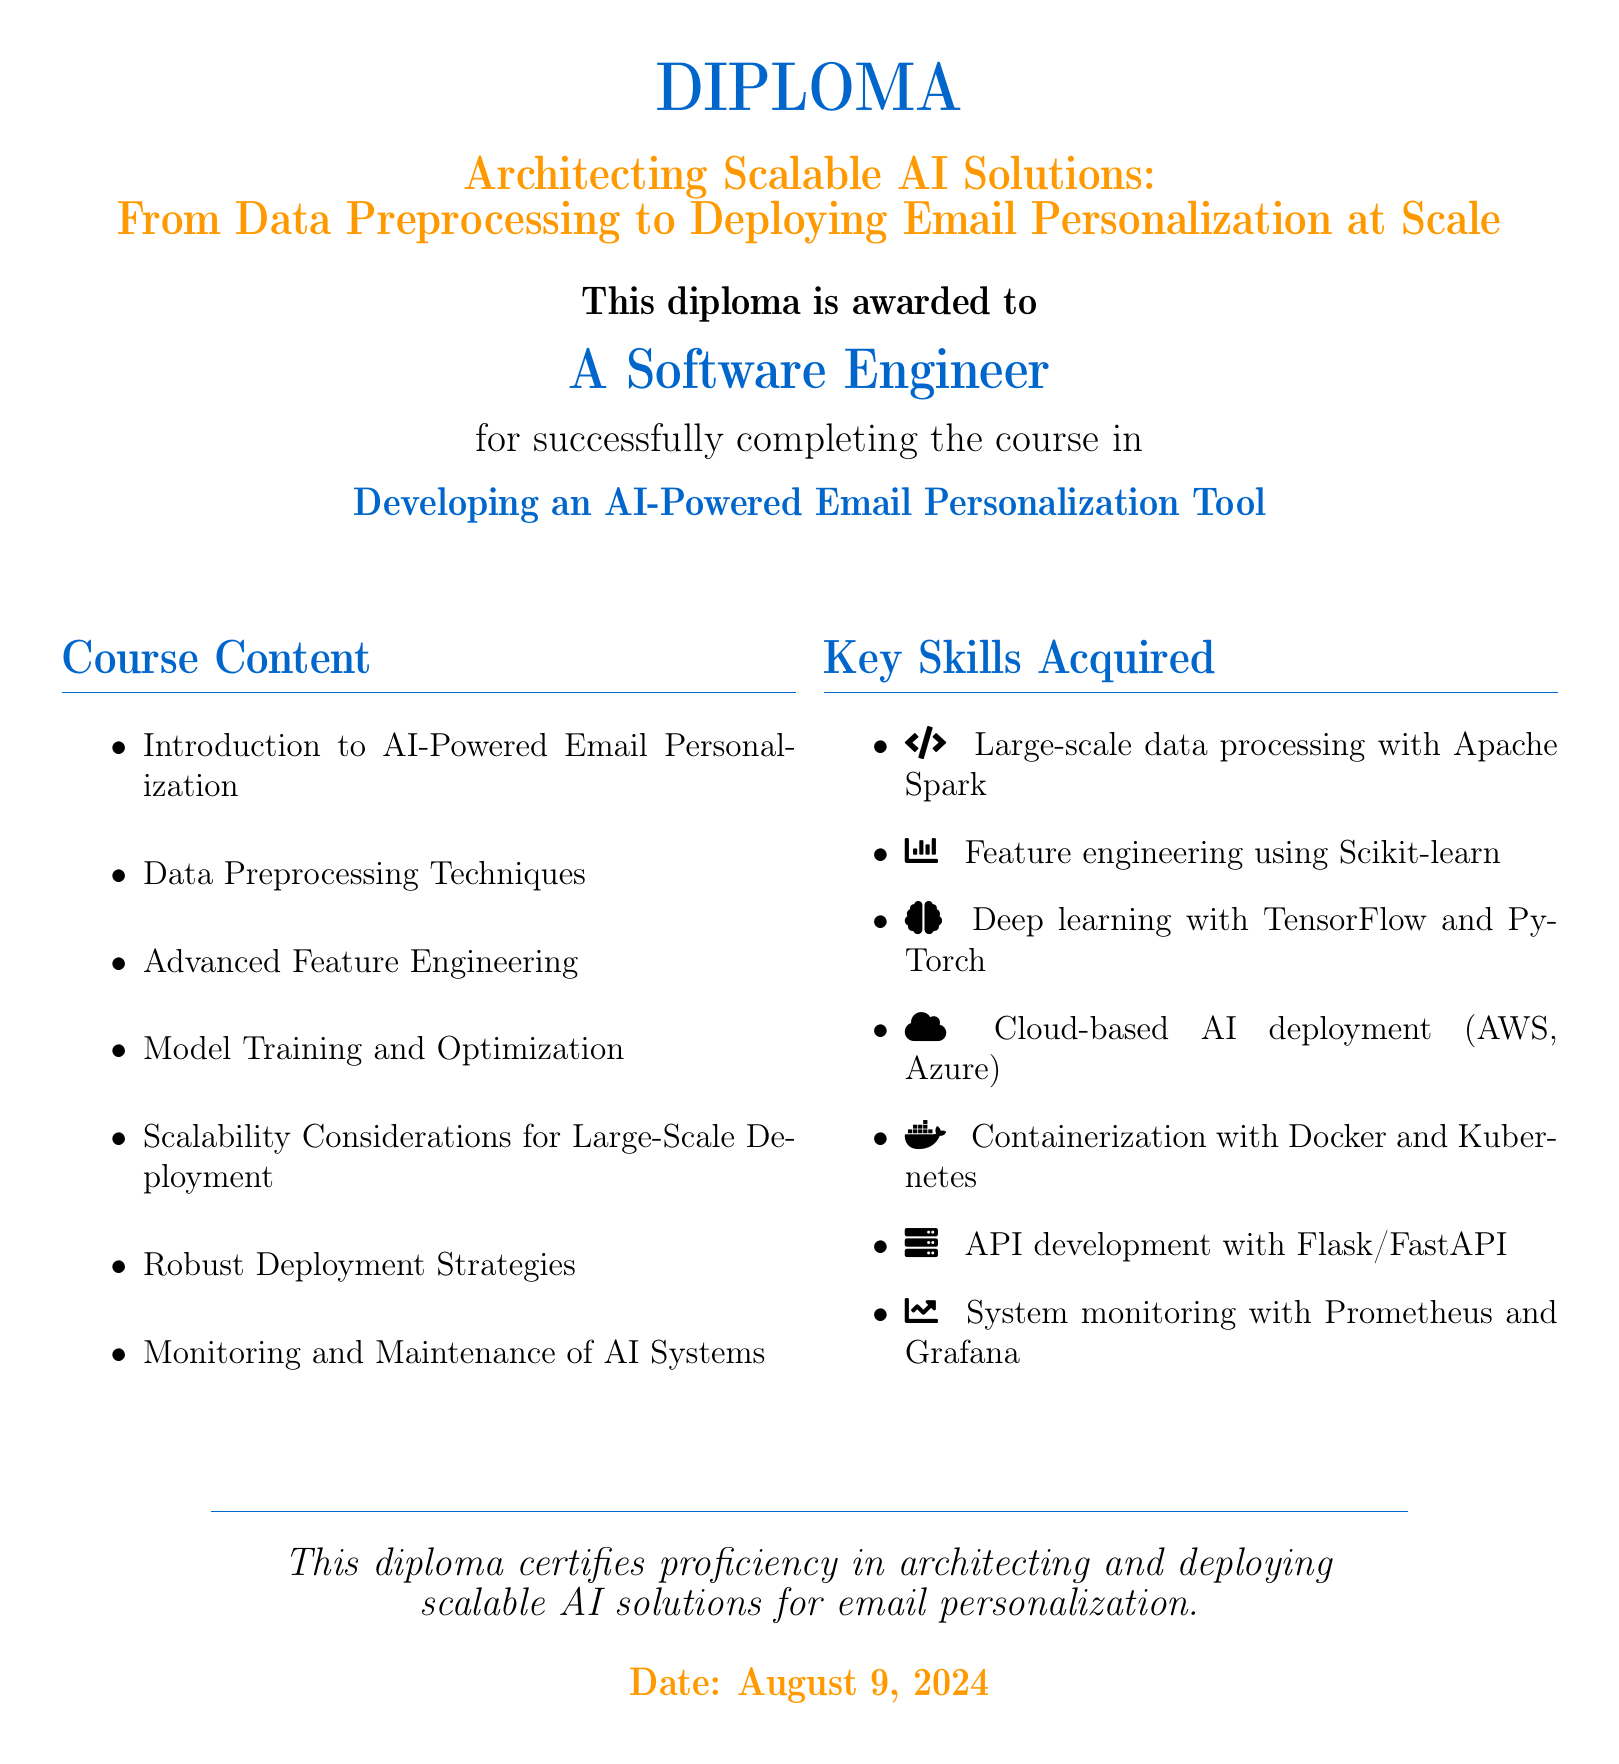What is the title of the diploma? The title is prominently displayed in the document and is "Architecting Scalable AI Solutions: From Data Preprocessing to Deploying Email Personalization at Scale."
Answer: Architecting Scalable AI Solutions: From Data Preprocessing to Deploying Email Personalization at Scale Who is the diploma awarded to? The diploma specifies who receives the award, stating "A Software Engineer."
Answer: A Software Engineer What is the course completion titled? The document states the course completion title, which is "Developing an AI-Powered Email Personalization Tool."
Answer: Developing an AI-Powered Email Personalization Tool How many key skills are acquired listed? The document provides a list of key skills, which includes a total of seven items.
Answer: Seven Which platform is mentioned for cloud-based AI deployment? The document lists specific cloud platforms for deployment, prominently featuring "AWS" and "Azure."
Answer: AWS, Azure What technique is used for large-scale data processing? The document refers to a specific technology for data processing, which is "Apache Spark."
Answer: Apache Spark Name two frameworks mentioned for deep learning. The document lists frameworks, and the two mentioned are "TensorFlow" and "PyTorch."
Answer: TensorFlow, PyTorch What does the diploma certify proficiency in? The diploma states its purpose clearly, certifying proficiency in "architecting and deploying scalable AI solutions for email personalization."
Answer: Architecting and deploying scalable AI solutions for email personalization When is the diploma dated? The document includes a date, which is dynamically generated and states "Date: Today."
Answer: Today 